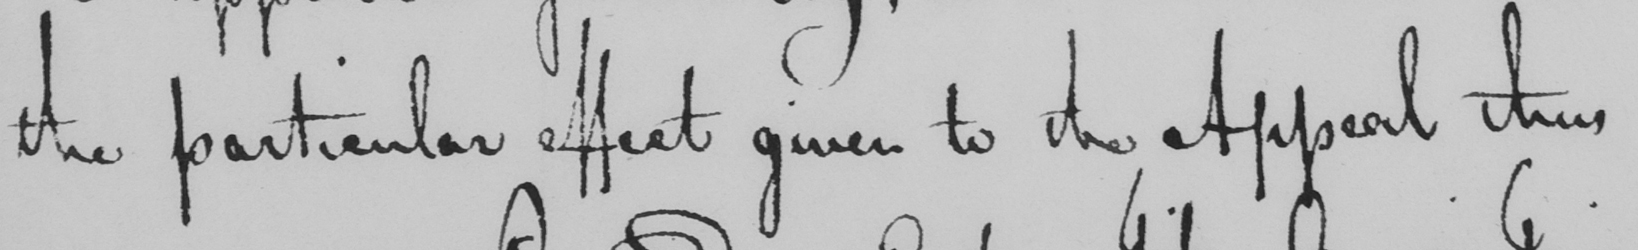Please transcribe the handwritten text in this image. the particular effect given to the Appeal thus 